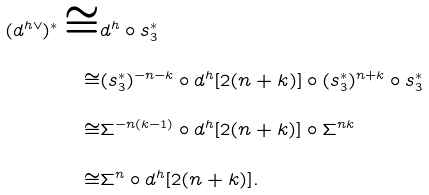Convert formula to latex. <formula><loc_0><loc_0><loc_500><loc_500>( d ^ { h \vee } ) ^ { * } \cong & d ^ { h } \circ s _ { 3 } ^ { * } \\ \cong & ( s _ { 3 } ^ { * } ) ^ { - n - k } \circ d ^ { h } [ 2 ( n + k ) ] \circ ( s _ { 3 } ^ { * } ) ^ { n + k } \circ s _ { 3 } ^ { * } \\ \cong & \Sigma ^ { - n ( k - 1 ) } \circ d ^ { h } [ 2 ( n + k ) ] \circ \Sigma ^ { n k } \\ \cong & \Sigma ^ { n } \circ d ^ { h } [ 2 ( n + k ) ] .</formula> 